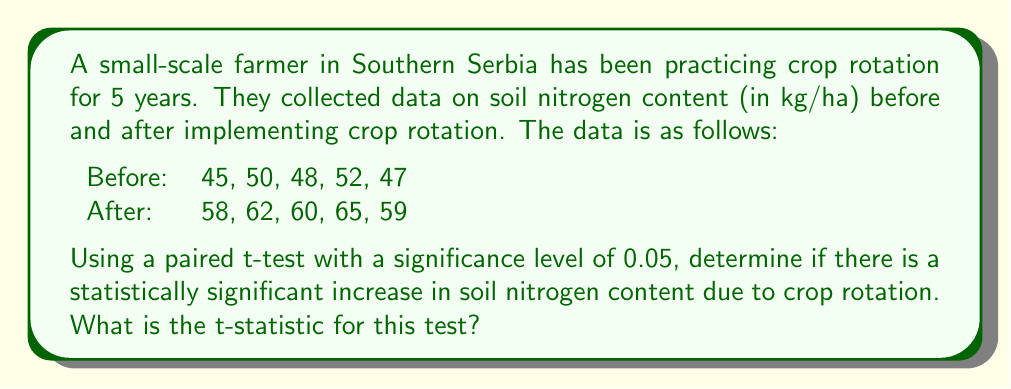Help me with this question. To solve this problem, we'll follow these steps:

1) Calculate the differences between paired observations:
   $d_i = \text{After}_i - \text{Before}_i$
   $d_1 = 58 - 45 = 13$
   $d_2 = 62 - 50 = 12$
   $d_3 = 60 - 48 = 12$
   $d_4 = 65 - 52 = 13$
   $d_5 = 59 - 47 = 12$

2) Calculate the mean difference:
   $$\bar{d} = \frac{\sum_{i=1}^n d_i}{n} = \frac{13 + 12 + 12 + 13 + 12}{5} = 12.4$$

3) Calculate the standard deviation of the differences:
   $$s_d = \sqrt{\frac{\sum_{i=1}^n (d_i - \bar{d})^2}{n-1}}$$
   $$s_d = \sqrt{\frac{(13-12.4)^2 + (12-12.4)^2 + (12-12.4)^2 + (13-12.4)^2 + (12-12.4)^2}{4}}$$
   $$s_d = \sqrt{\frac{0.36 + 0.16 + 0.16 + 0.36 + 0.16}{4}} = \sqrt{0.3} = 0.5477$$

4) Calculate the t-statistic:
   $$t = \frac{\bar{d}}{s_d / \sqrt{n}}$$
   $$t = \frac{12.4}{0.5477 / \sqrt{5}} = \frac{12.4}{0.2449} = 50.63$$

Therefore, the t-statistic for this paired t-test is approximately 50.63.
Answer: 50.63 